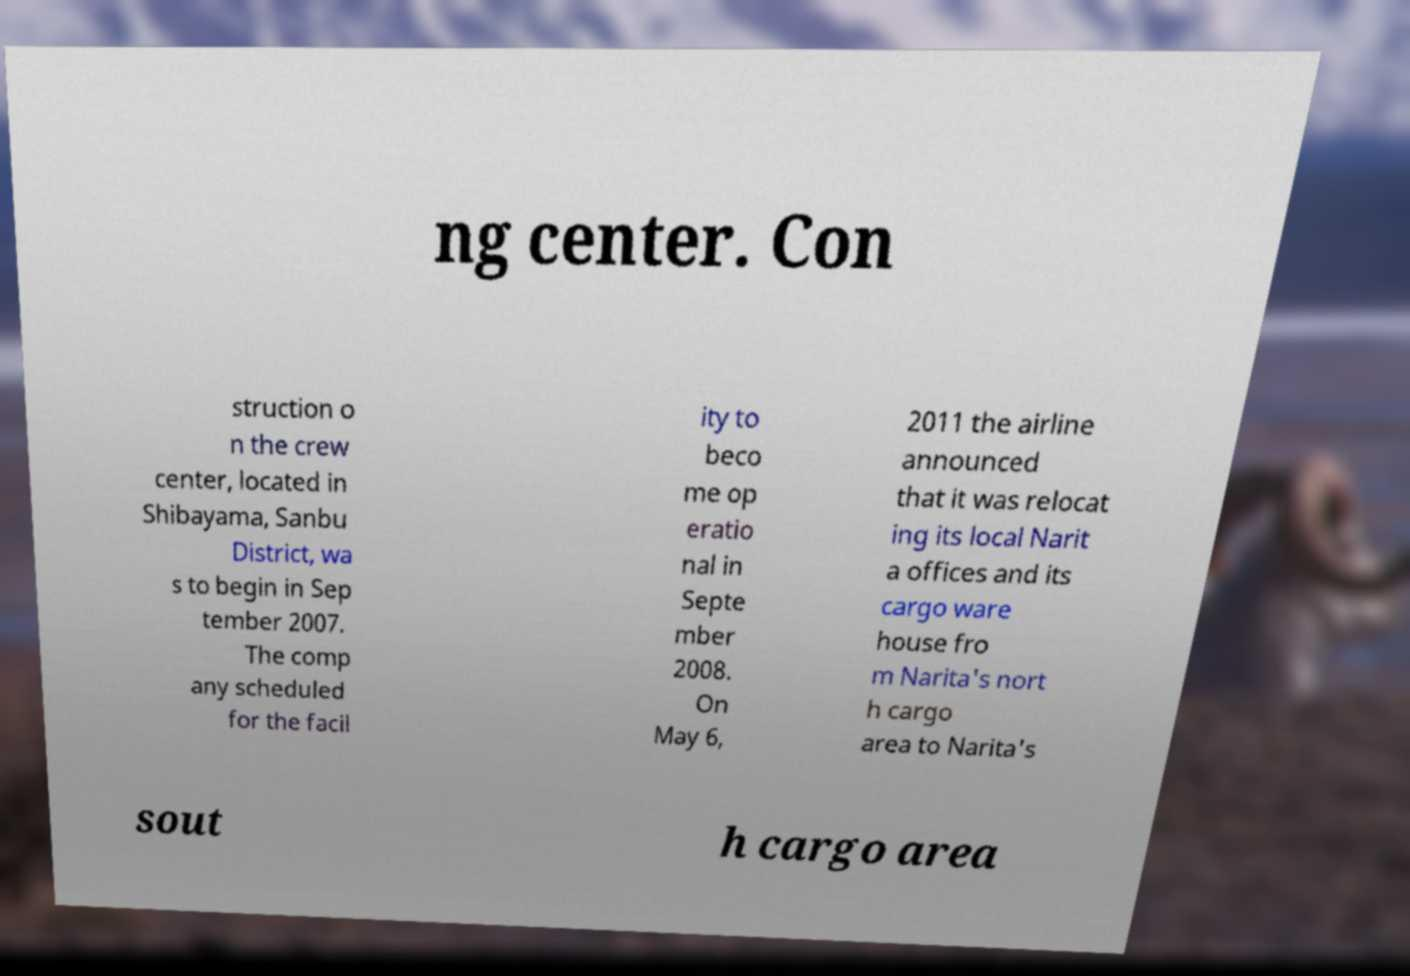For documentation purposes, I need the text within this image transcribed. Could you provide that? ng center. Con struction o n the crew center, located in Shibayama, Sanbu District, wa s to begin in Sep tember 2007. The comp any scheduled for the facil ity to beco me op eratio nal in Septe mber 2008. On May 6, 2011 the airline announced that it was relocat ing its local Narit a offices and its cargo ware house fro m Narita's nort h cargo area to Narita's sout h cargo area 